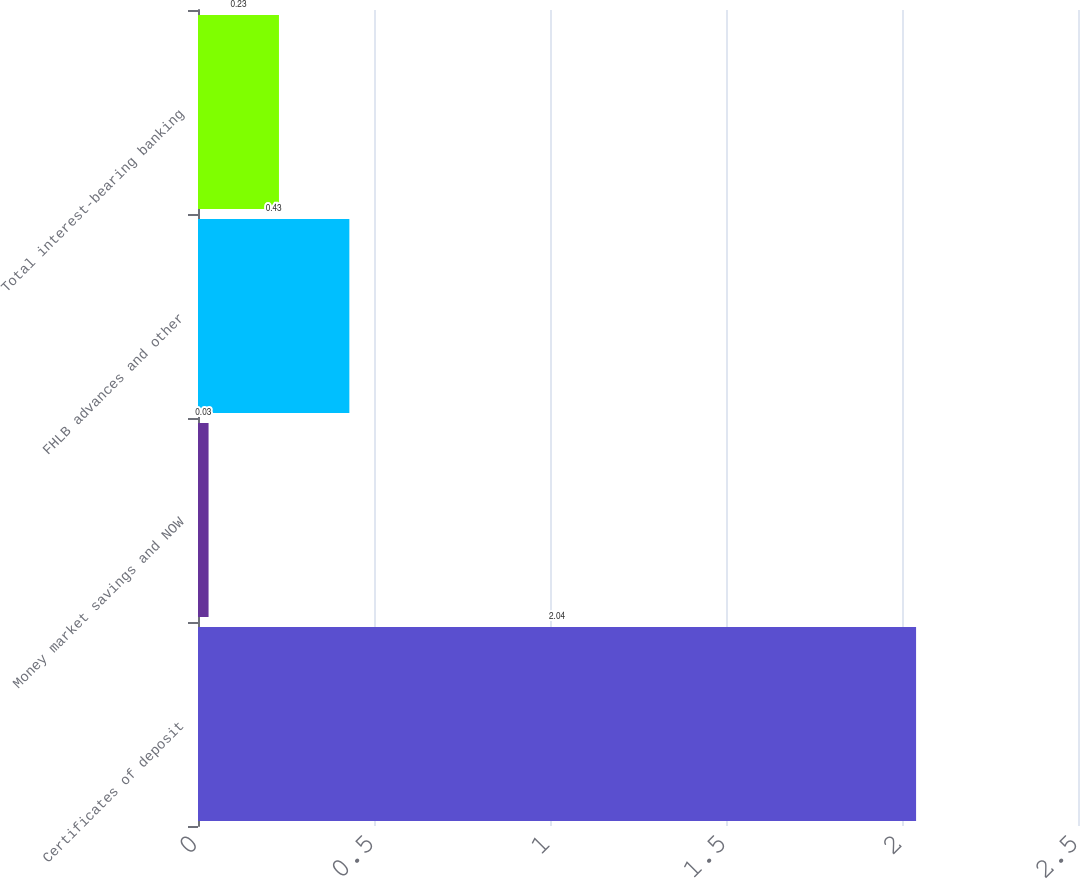Convert chart to OTSL. <chart><loc_0><loc_0><loc_500><loc_500><bar_chart><fcel>Certificates of deposit<fcel>Money market savings and NOW<fcel>FHLB advances and other<fcel>Total interest-bearing banking<nl><fcel>2.04<fcel>0.03<fcel>0.43<fcel>0.23<nl></chart> 